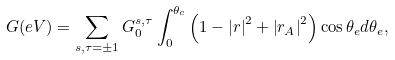<formula> <loc_0><loc_0><loc_500><loc_500>G ( e V ) = \sum _ { s , \tau = \pm 1 } G ^ { s , \tau } _ { 0 } \int ^ { \theta _ { c } } _ { 0 } \left ( 1 - \left | r \right | ^ { 2 } + \left | r _ { A } \right | ^ { 2 } \right ) \cos { \theta _ { e } } d \theta _ { e } ,</formula> 